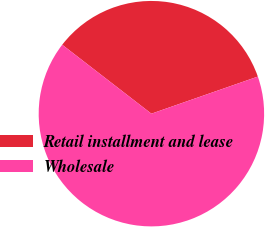Convert chart to OTSL. <chart><loc_0><loc_0><loc_500><loc_500><pie_chart><fcel>Retail installment and lease<fcel>Wholesale<nl><fcel>34.19%<fcel>65.81%<nl></chart> 